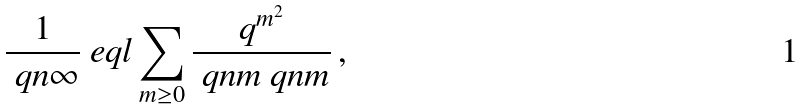<formula> <loc_0><loc_0><loc_500><loc_500>\frac { 1 } { \ q n { \infty } } \ e q l \sum _ { m \geq 0 } \frac { q ^ { m ^ { 2 } } } { \ q n { m } \ q n { m } } \, ,</formula> 